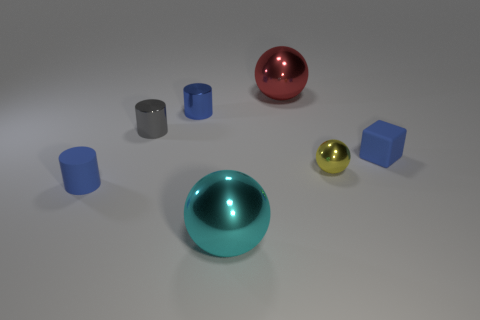Add 1 big cyan matte balls. How many objects exist? 8 Subtract all cylinders. How many objects are left? 4 Subtract 1 spheres. How many spheres are left? 2 Subtract all cyan cylinders. Subtract all gray cubes. How many cylinders are left? 3 Subtract all cyan cubes. How many red balls are left? 1 Subtract all red metal things. Subtract all blue matte cylinders. How many objects are left? 5 Add 6 large metallic balls. How many large metallic balls are left? 8 Add 1 small balls. How many small balls exist? 2 Subtract all blue cylinders. How many cylinders are left? 1 Subtract all big cyan metallic spheres. How many spheres are left? 2 